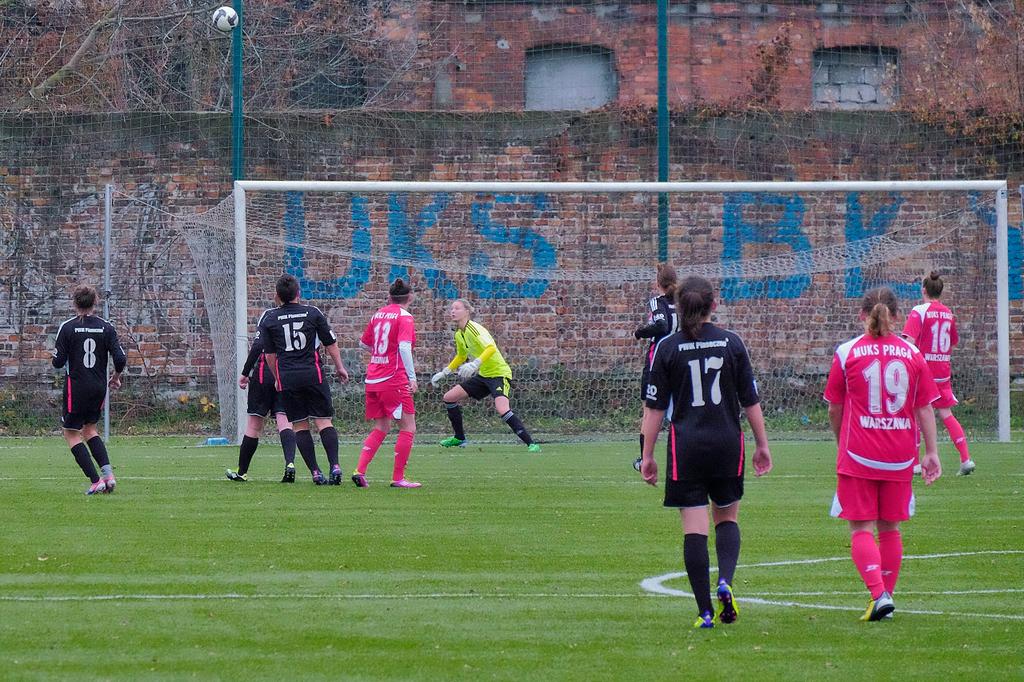What sport is this?
Offer a terse response. Answering does not require reading text in the image. 